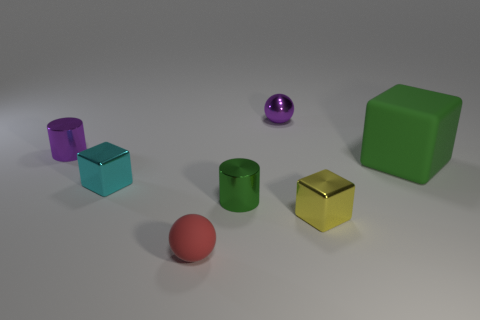Subtract all green cubes. How many cubes are left? 2 Subtract all cyan cubes. How many cubes are left? 2 Add 3 matte blocks. How many objects exist? 10 Subtract all spheres. How many objects are left? 5 Subtract 1 balls. How many balls are left? 1 Subtract all purple cylinders. How many red blocks are left? 0 Subtract all tiny red spheres. Subtract all shiny spheres. How many objects are left? 5 Add 6 small cyan shiny objects. How many small cyan shiny objects are left? 7 Add 7 big blue metallic cubes. How many big blue metallic cubes exist? 7 Subtract 0 brown blocks. How many objects are left? 7 